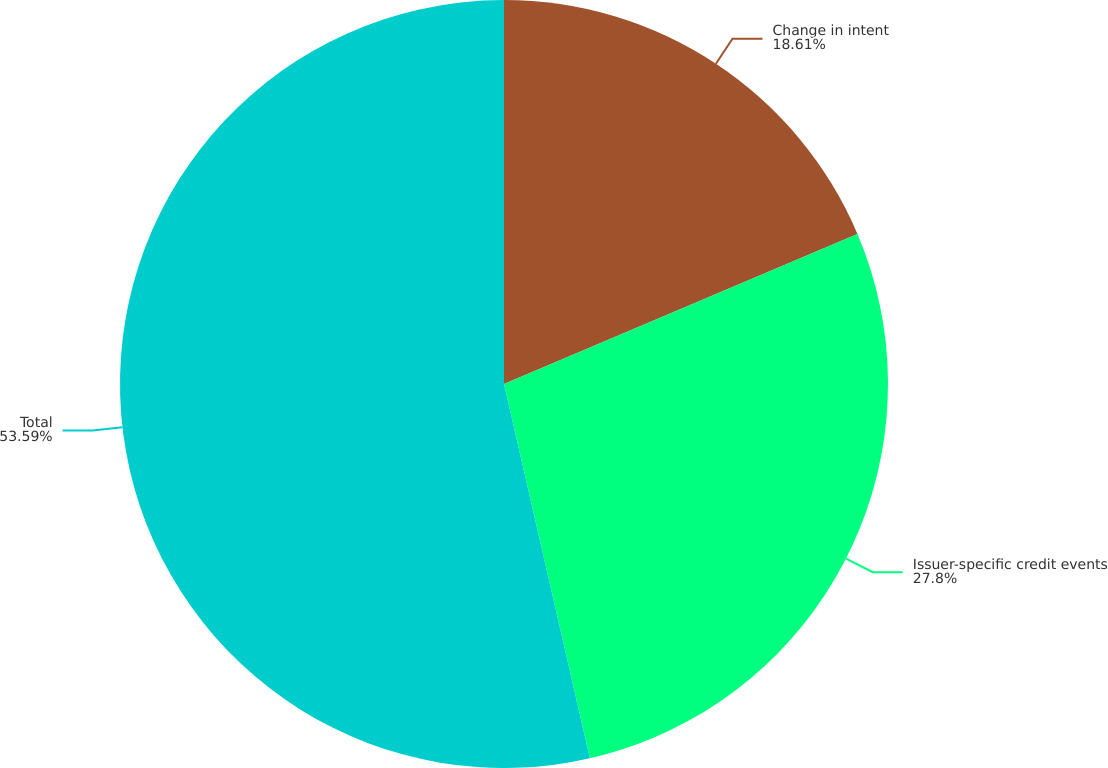<chart> <loc_0><loc_0><loc_500><loc_500><pie_chart><fcel>Change in intent<fcel>Issuer-specific credit events<fcel>Total<nl><fcel>18.61%<fcel>27.8%<fcel>53.59%<nl></chart> 